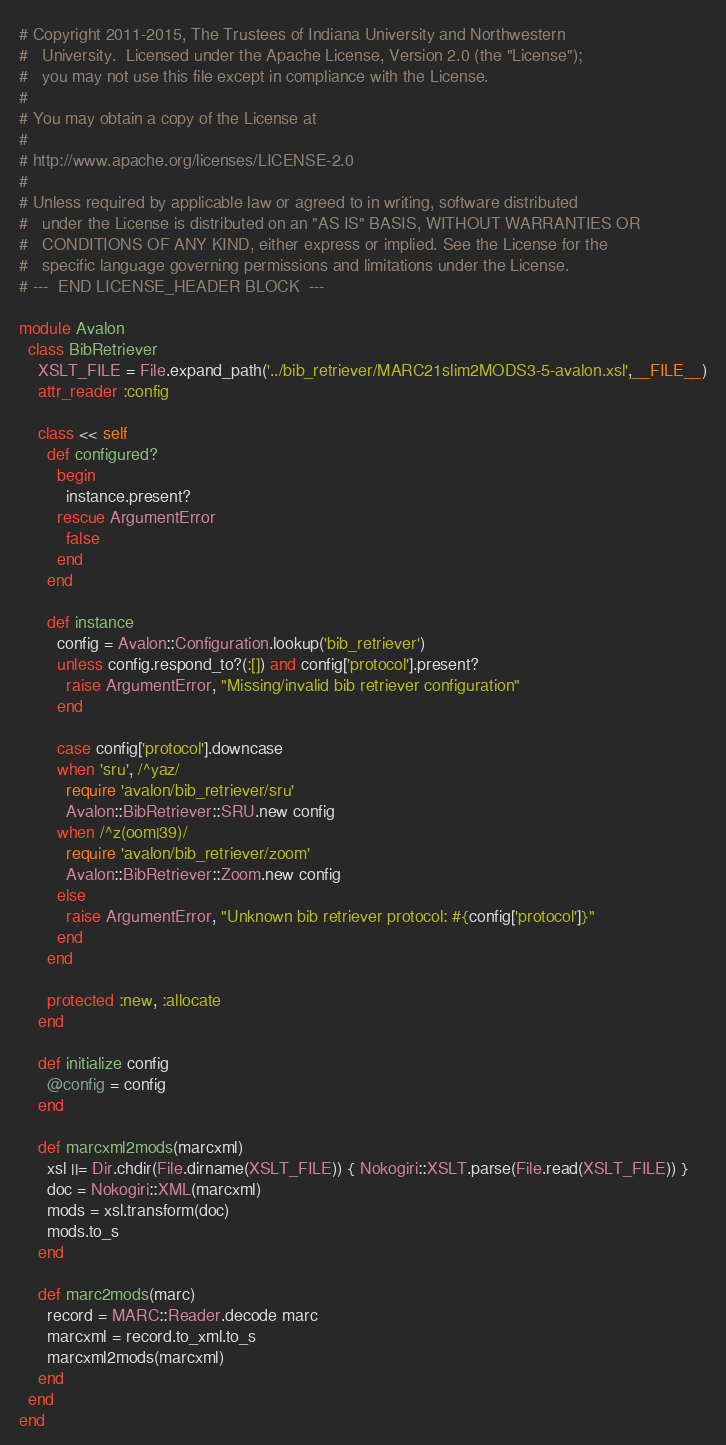<code> <loc_0><loc_0><loc_500><loc_500><_Ruby_># Copyright 2011-2015, The Trustees of Indiana University and Northwestern
#   University.  Licensed under the Apache License, Version 2.0 (the "License");
#   you may not use this file except in compliance with the License.
# 
# You may obtain a copy of the License at
# 
# http://www.apache.org/licenses/LICENSE-2.0
# 
# Unless required by applicable law or agreed to in writing, software distributed 
#   under the License is distributed on an "AS IS" BASIS, WITHOUT WARRANTIES OR
#   CONDITIONS OF ANY KIND, either express or implied. See the License for the 
#   specific language governing permissions and limitations under the License.
# ---  END LICENSE_HEADER BLOCK  ---

module Avalon
  class BibRetriever
    XSLT_FILE = File.expand_path('../bib_retriever/MARC21slim2MODS3-5-avalon.xsl',__FILE__)
    attr_reader :config
    
    class << self
      def configured?
        begin
          instance.present?
        rescue ArgumentError
          false
        end
      end
      
      def instance
        config = Avalon::Configuration.lookup('bib_retriever')
        unless config.respond_to?(:[]) and config['protocol'].present?
          raise ArgumentError, "Missing/invalid bib retriever configuration" 
        end
        
        case config['protocol'].downcase
        when 'sru', /^yaz/
          require 'avalon/bib_retriever/sru'
          Avalon::BibRetriever::SRU.new config
        when /^z(oom|39)/
          require 'avalon/bib_retriever/zoom'
          Avalon::BibRetriever::Zoom.new config
        else
          raise ArgumentError, "Unknown bib retriever protocol: #{config['protocol']}"
        end
      end
      
      protected :new, :allocate
    end
    
    def initialize config
      @config = config
    end

    def marcxml2mods(marcxml)
      xsl ||= Dir.chdir(File.dirname(XSLT_FILE)) { Nokogiri::XSLT.parse(File.read(XSLT_FILE)) }
      doc = Nokogiri::XML(marcxml)
      mods = xsl.transform(doc)
      mods.to_s
    end
    
    def marc2mods(marc)
      record = MARC::Reader.decode marc
      marcxml = record.to_xml.to_s
      marcxml2mods(marcxml)
    end
  end
end
</code> 